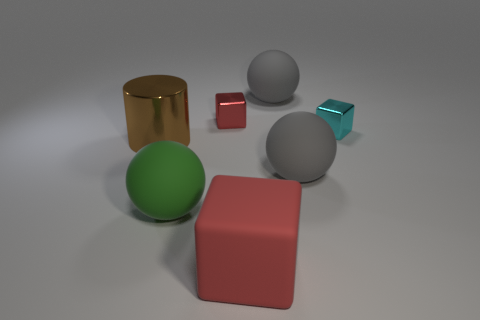There is a cyan thing that is the same shape as the big red object; what is its material?
Ensure brevity in your answer.  Metal. What number of small cubes are the same color as the large rubber cube?
Your answer should be compact. 1. How many objects are big blue rubber spheres or large gray matte objects that are behind the big brown object?
Give a very brief answer. 1. Is there a cyan cylinder made of the same material as the green sphere?
Give a very brief answer. No. How many shiny objects are left of the green thing and behind the large metal cylinder?
Make the answer very short. 0. There is a large brown thing to the left of the large matte cube; what is it made of?
Provide a short and direct response. Metal. There is a cyan block that is made of the same material as the tiny red block; what size is it?
Provide a succinct answer. Small. There is a red shiny block; are there any large gray spheres behind it?
Ensure brevity in your answer.  Yes. What is the size of the cyan object that is the same shape as the tiny red thing?
Provide a succinct answer. Small. Is the color of the big cube the same as the metal cube behind the cyan block?
Give a very brief answer. Yes. 